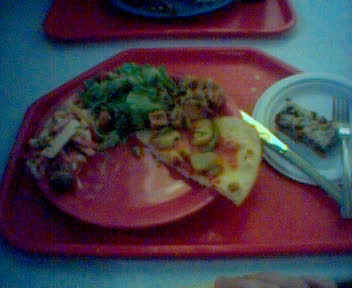<image>What type of meat is shown? I am not sure about the type of meat shown. It could be beef, sausage, or no meat at all. What type of meat is shown? I am not sure what type of meat is shown. It can be beef, pizza, sausage, or something else. 